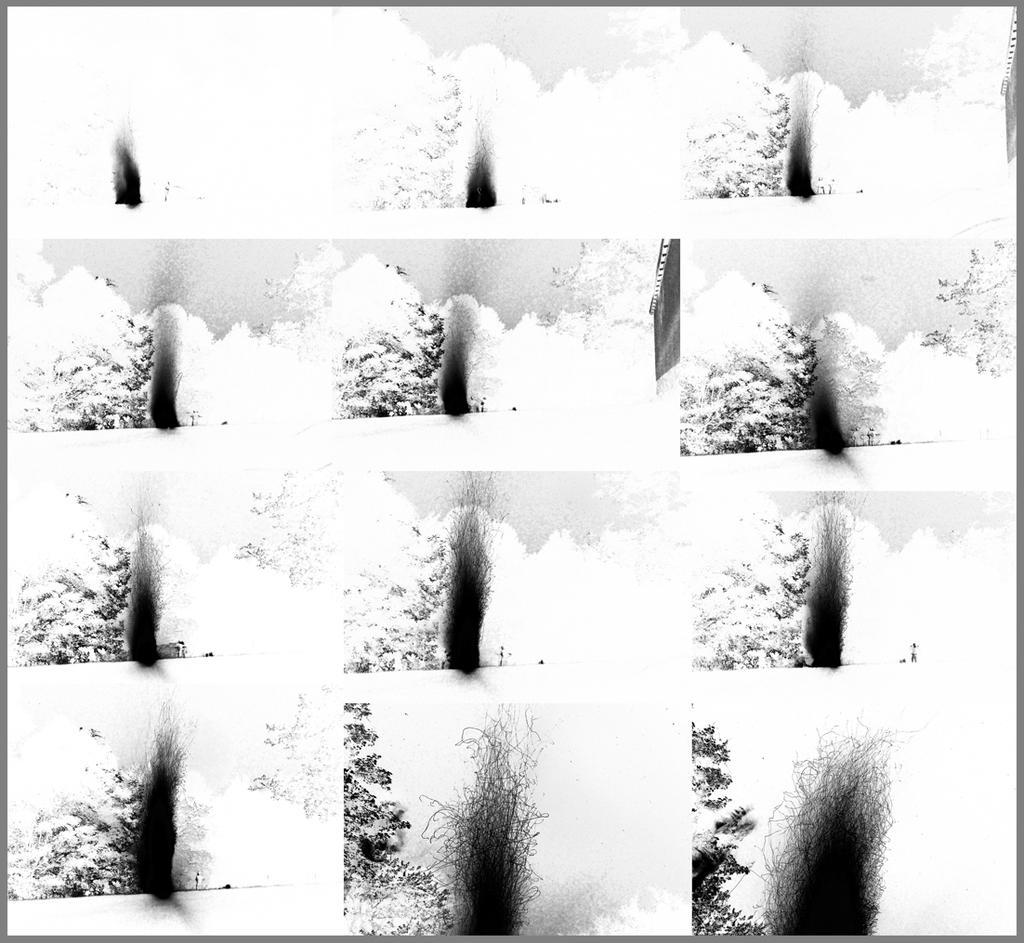Could you give a brief overview of what you see in this image? A collage pictures. In these pictures we can see trees. 